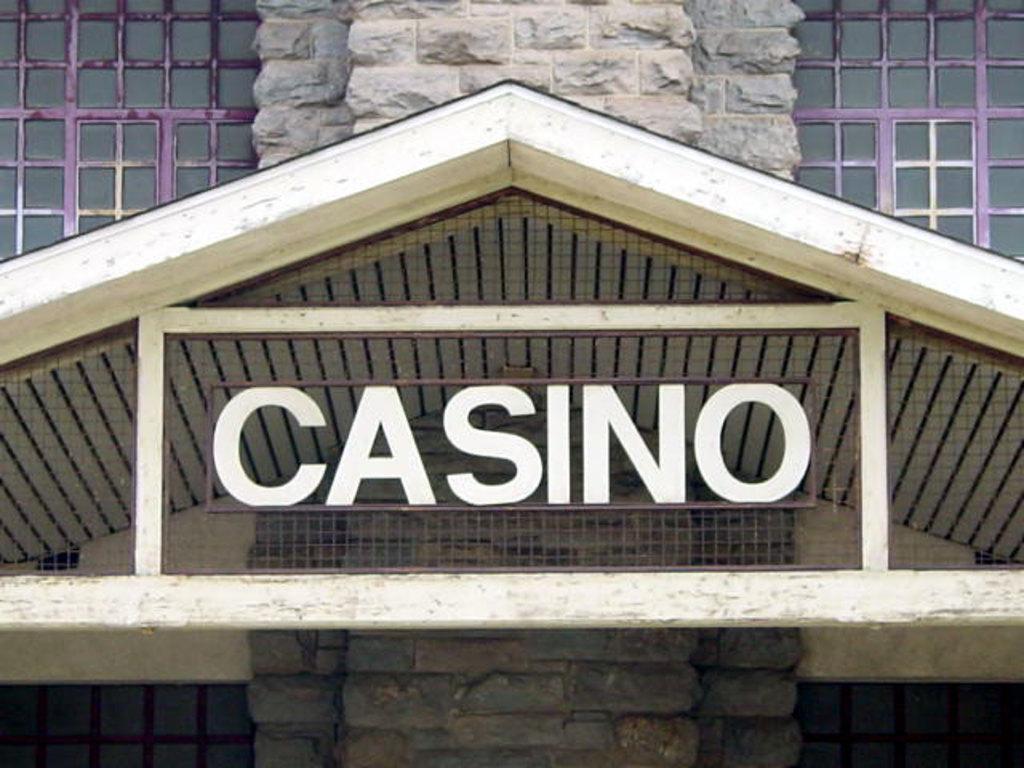Describe this image in one or two sentences. In this picture I can see the roof. I can see the metal grill fence. I can see glass windows. 